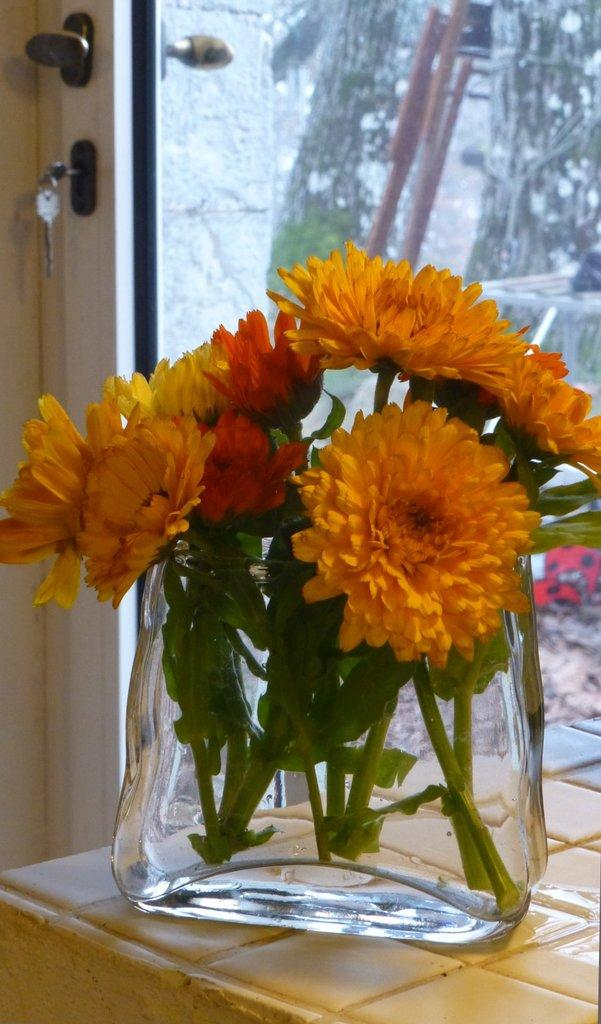What type of objects are present in the image? There are flowers, a glass vase, and keys in the image. What colors are the flowers? The flowers are in red, yellow, and orange colors. Where is the vase located? The vase is on the cream-colored floor. What can be seen through the glass door in the image? The contents or view through the glass door are not visible in the image. What is the vase holding? The vase is holding flowers. What type of screw can be seen in the image? There is no screw present in the image. What type of business is being conducted in the image? The image does not depict any business activity. 